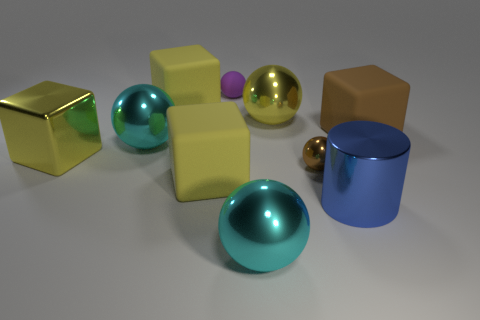There is a big rubber cube that is on the left side of the big matte object in front of the brown matte cube right of the brown sphere; what color is it?
Provide a short and direct response. Yellow. Are there any large cyan shiny things of the same shape as the large brown thing?
Make the answer very short. No. What number of small yellow spheres are there?
Provide a succinct answer. 0. The blue thing has what shape?
Your answer should be compact. Cylinder. What number of purple objects are the same size as the yellow ball?
Offer a very short reply. 0. Is the shape of the small matte object the same as the small brown shiny thing?
Provide a short and direct response. Yes. There is a large metallic ball that is on the right side of the cyan ball that is in front of the large cylinder; what is its color?
Make the answer very short. Yellow. What size is the metal sphere that is both behind the tiny brown ball and to the right of the purple object?
Your answer should be compact. Large. Is there any other thing that is the same color as the rubber sphere?
Provide a succinct answer. No. What shape is the brown object that is made of the same material as the big cylinder?
Your answer should be very brief. Sphere. 